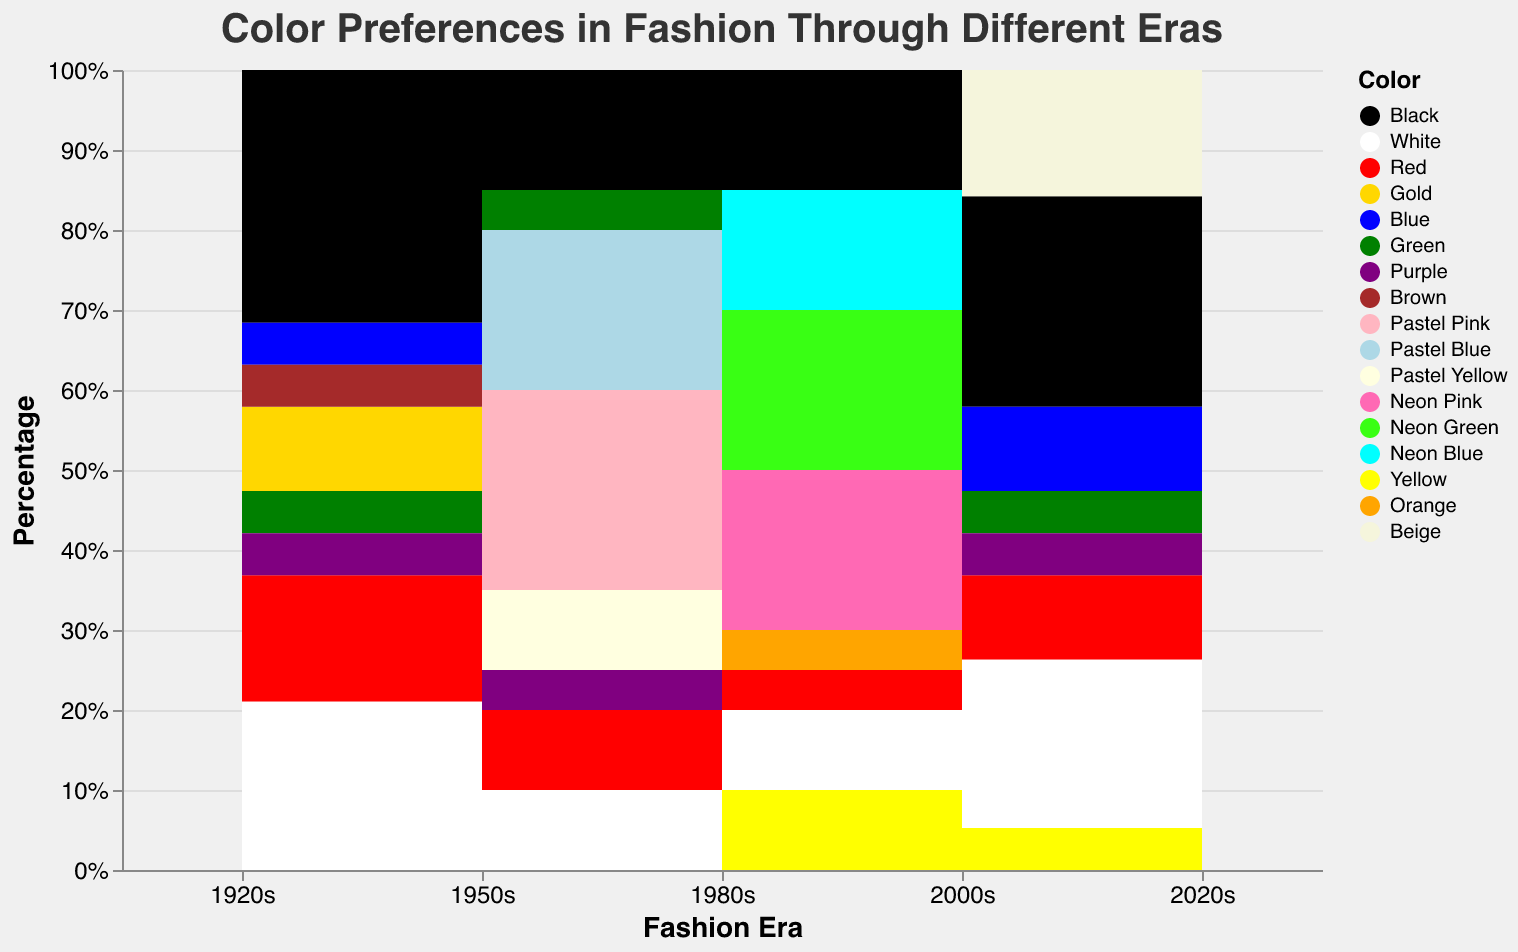what is the main title of the figure? The main title of the figure is prominently displayed at the top.
Answer: Color Preferences in Fashion Through Different Eras What era has the highest percentage of the color Neon Pink? To find the era with the highest percentage of Neon Pink, look vertically at the "Neon Pink" color segments across all eras.
Answer: 1980s How does the usage of black compare between the 1920s and the 2020s? Observe the height of the segment representing "Black" in both the 1920s and the 2020s, then compare their relative percentages.
Answer: Higher in the 1920s Which era introduced the highest variety of pastel colors? Count the number of distinct pastel colors (like Pastel Pink, Pastel Blue, etc.) in each era. The era with the most distinct pastel colors has the highest variety.
Answer: 1950s What is the combined percentage of neon colors in the 1980s? Add the percentages of Neon Pink, Neon Green, and Neon Blue for the 1980s. This involves additive operations.
Answer: 55% Which colors were present in both the 1920s and 2000s? Identify colors that appear under both the 1920s and 2000s era segments.
Answer: Black, White, Red, Blue, Green, Purple Did the usage of white increase or decrease from the 2000s to the 2020s? Compare the segment height representing "White" in the 2000s against the same in the 2020s to see if it is taller or shorter.
Answer: Decrease What percentage of colors in the 2020s are not carried over from the 2000s? List the colors in the 2020s that do not appear in the 2000s, and then sum their percentages.
Answer: 15% What is the dominant color in the 2000s era? Identify the color with the largest segment in the 2000s based on its percentage.
Answer: Black Which colors were only fashionable in one specific era? Identify colors that appear in only one era by scanning through each era and noting unique entries.
Answer: Brown (1920s), Neon Pink (1980s), Neon Green (1980s), Neon Blue (1980s), Orange (1980s) 